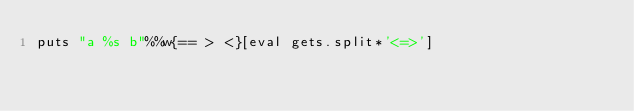Convert code to text. <code><loc_0><loc_0><loc_500><loc_500><_Ruby_>puts "a %s b"%%w{== > <}[eval gets.split*'<=>']</code> 